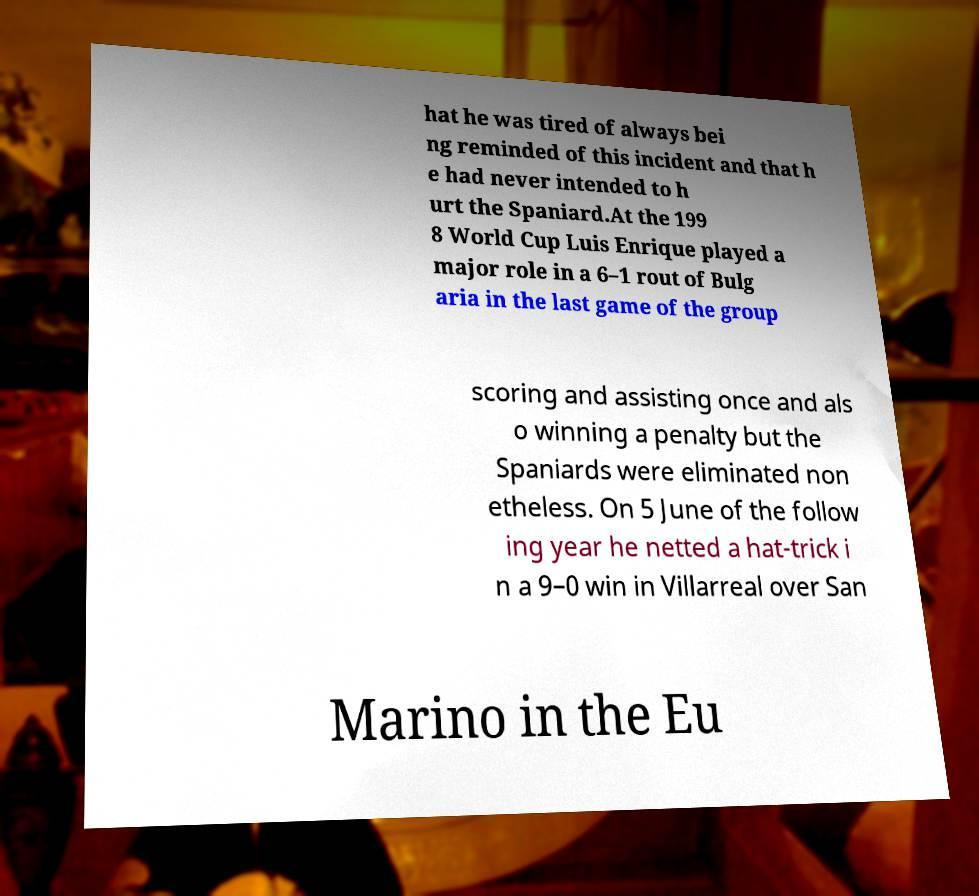For documentation purposes, I need the text within this image transcribed. Could you provide that? hat he was tired of always bei ng reminded of this incident and that h e had never intended to h urt the Spaniard.At the 199 8 World Cup Luis Enrique played a major role in a 6–1 rout of Bulg aria in the last game of the group scoring and assisting once and als o winning a penalty but the Spaniards were eliminated non etheless. On 5 June of the follow ing year he netted a hat-trick i n a 9–0 win in Villarreal over San Marino in the Eu 